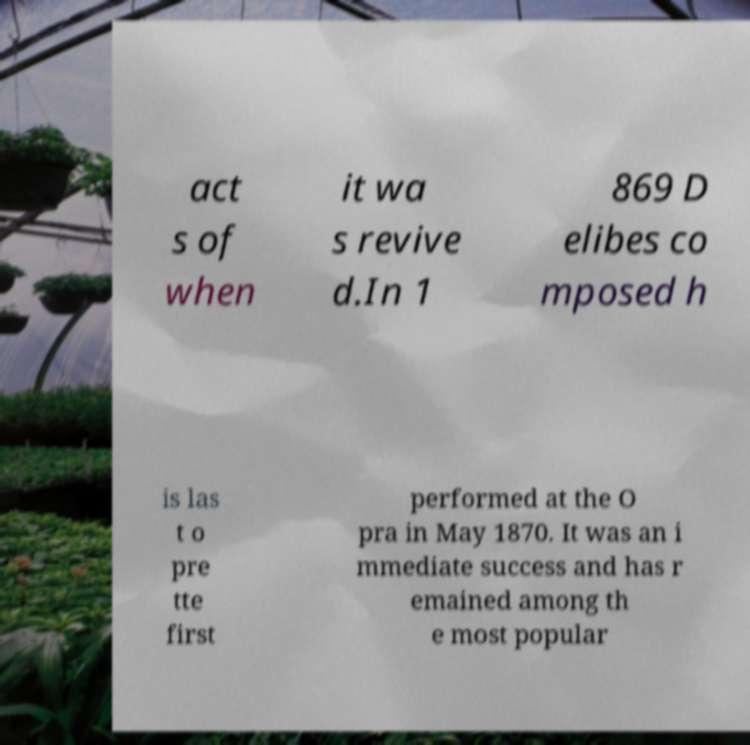Can you read and provide the text displayed in the image?This photo seems to have some interesting text. Can you extract and type it out for me? act s of when it wa s revive d.In 1 869 D elibes co mposed h is las t o pre tte first performed at the O pra in May 1870. It was an i mmediate success and has r emained among th e most popular 